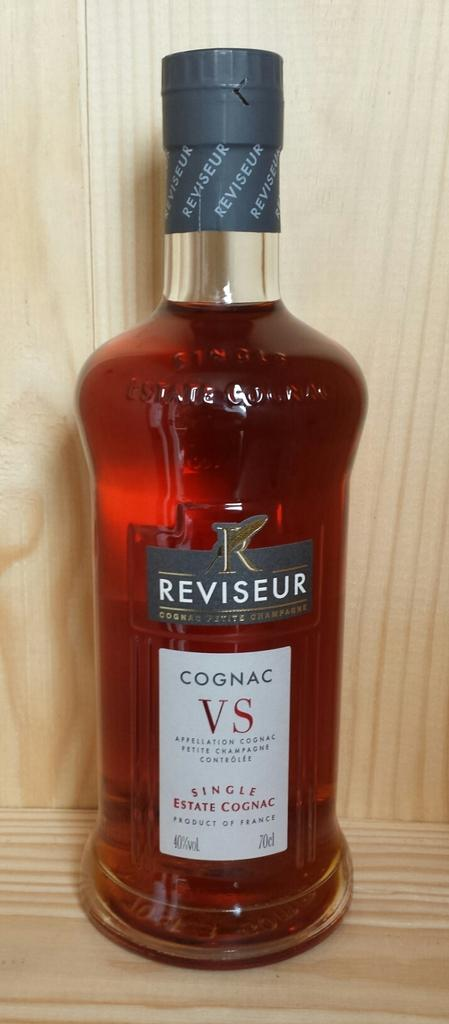<image>
Share a concise interpretation of the image provided. A large full bottle of Reviseur brand cognac. 